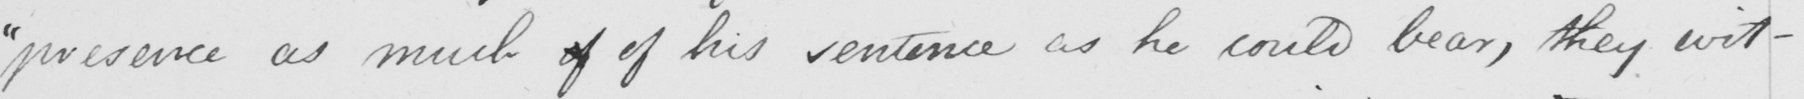What text is written in this handwritten line? " presence as much if of his sentence as he could bear , they wit- 